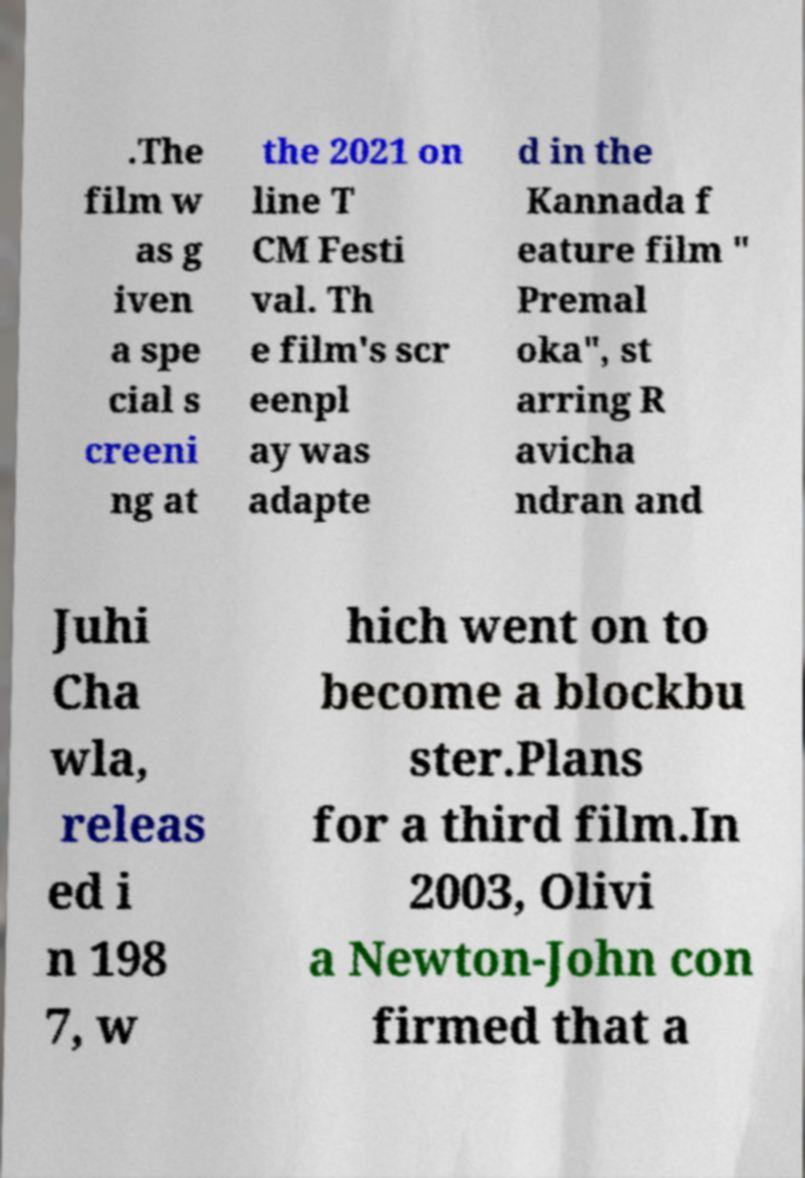What messages or text are displayed in this image? I need them in a readable, typed format. .The film w as g iven a spe cial s creeni ng at the 2021 on line T CM Festi val. Th e film's scr eenpl ay was adapte d in the Kannada f eature film " Premal oka", st arring R avicha ndran and Juhi Cha wla, releas ed i n 198 7, w hich went on to become a blockbu ster.Plans for a third film.In 2003, Olivi a Newton-John con firmed that a 